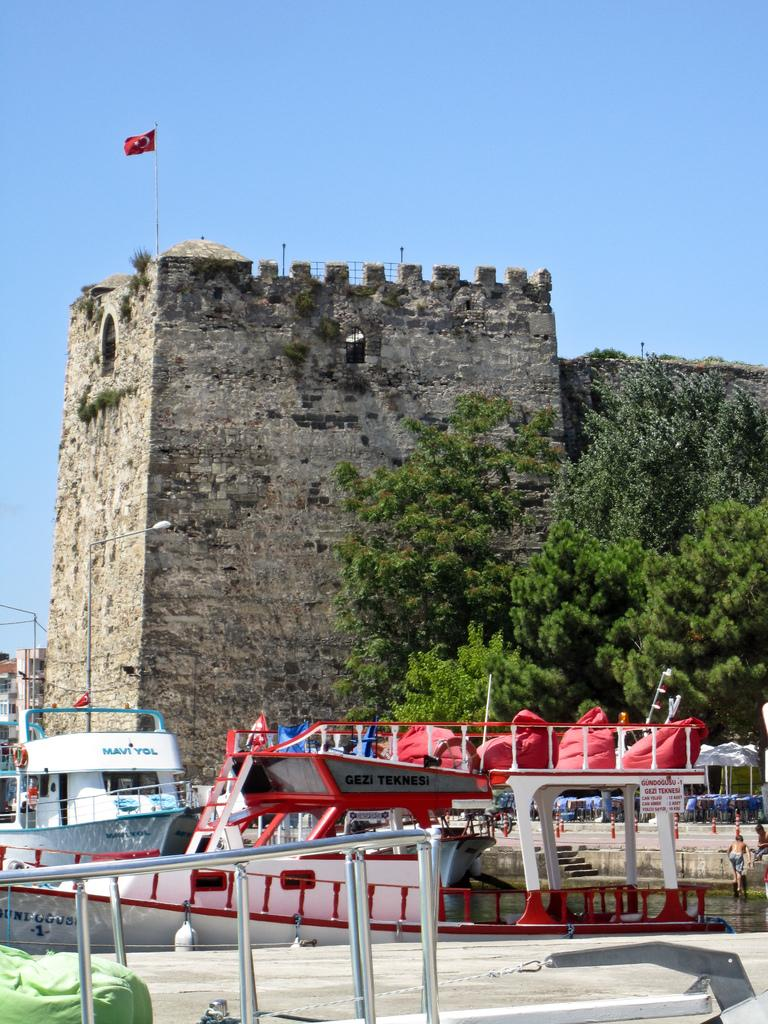What type of structure is the main subject of the image? There is a fort in the image. What natural elements can be seen in the image? There are trees and water visible in the image. What man-made structures are present in the image? There are boats, stairs, a walkway, rods, buildings, a pole with a light, and a fort in the image. Are there any people in the image? Yes, there are people in the image. What can be seen in the sky in the background of the image? The sky is visible in the background of the image. What type of beef is being served at the dock in the image? There is no dock or beef present in the image. What type of border can be seen between the buildings in the image? There is no border between the buildings in the image; they are simply adjacent structures. 